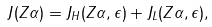<formula> <loc_0><loc_0><loc_500><loc_500>J ( Z \alpha ) = J _ { H } ( Z \alpha , \epsilon ) + J _ { L } ( Z \alpha , \epsilon ) ,</formula> 